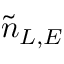Convert formula to latex. <formula><loc_0><loc_0><loc_500><loc_500>\tilde { n } _ { L , E }</formula> 